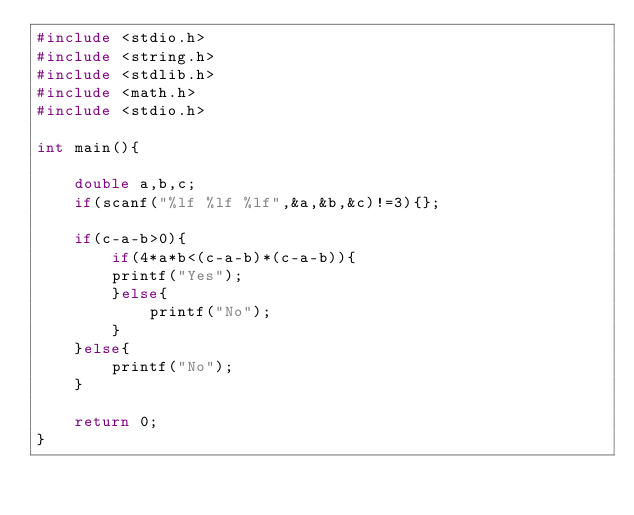<code> <loc_0><loc_0><loc_500><loc_500><_C_>#include <stdio.h>
#include <string.h>
#include <stdlib.h>
#include <math.h>
#include <stdio.h>

int main(){

    double a,b,c;
    if(scanf("%lf %lf %lf",&a,&b,&c)!=3){};
    
    if(c-a-b>0){
        if(4*a*b<(c-a-b)*(c-a-b)){
        printf("Yes");
        }else{
            printf("No");
        }
    }else{
        printf("No");
    }

    return 0;
}</code> 